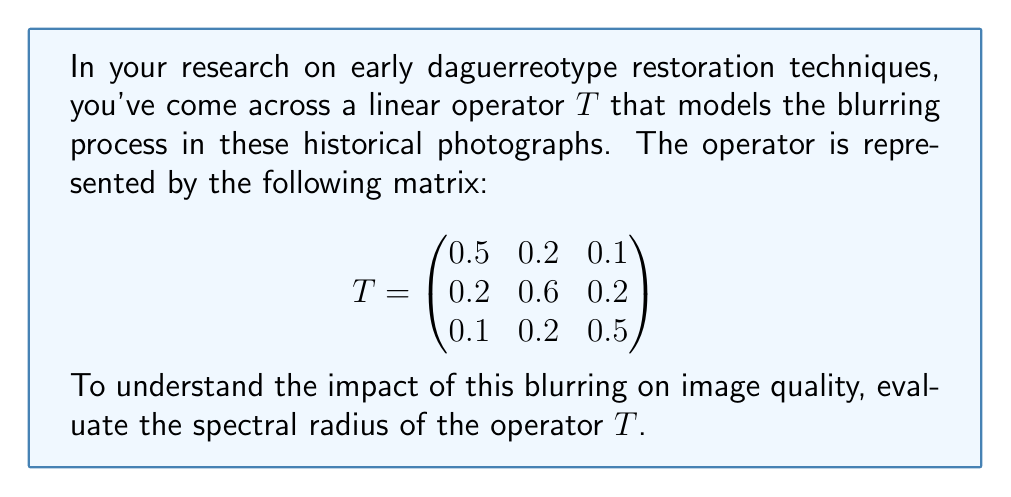Give your solution to this math problem. To find the spectral radius of the operator $T$, we follow these steps:

1) The spectral radius $\rho(T)$ is defined as:
   $$\rho(T) = \max\{|\lambda| : \lambda \text{ is an eigenvalue of } T\}$$

2) To find the eigenvalues, we solve the characteristic equation:
   $$\det(T - \lambda I) = 0$$

3) Expanding the determinant:
   $$\begin{vmatrix}
   0.5-\lambda & 0.2 & 0.1 \\
   0.2 & 0.6-\lambda & 0.2 \\
   0.1 & 0.2 & 0.5-\lambda
   \end{vmatrix} = 0$$

4) This gives us the characteristic polynomial:
   $$-\lambda^3 + 1.6\lambda^2 - 0.71\lambda + 0.088 = 0$$

5) Solving this equation (using a computer algebra system or numerical methods) yields the eigenvalues:
   $$\lambda_1 \approx 0.9053, \lambda_2 \approx 0.3973, \lambda_3 \approx 0.2974$$

6) Taking the absolute value of each eigenvalue:
   $$|\lambda_1| \approx 0.9053, |\lambda_2| \approx 0.3973, |\lambda_3| \approx 0.2974$$

7) The spectral radius is the maximum of these values:
   $$\rho(T) = \max\{0.9053, 0.3973, 0.2974\} = 0.9053$$
Answer: $\rho(T) \approx 0.9053$ 